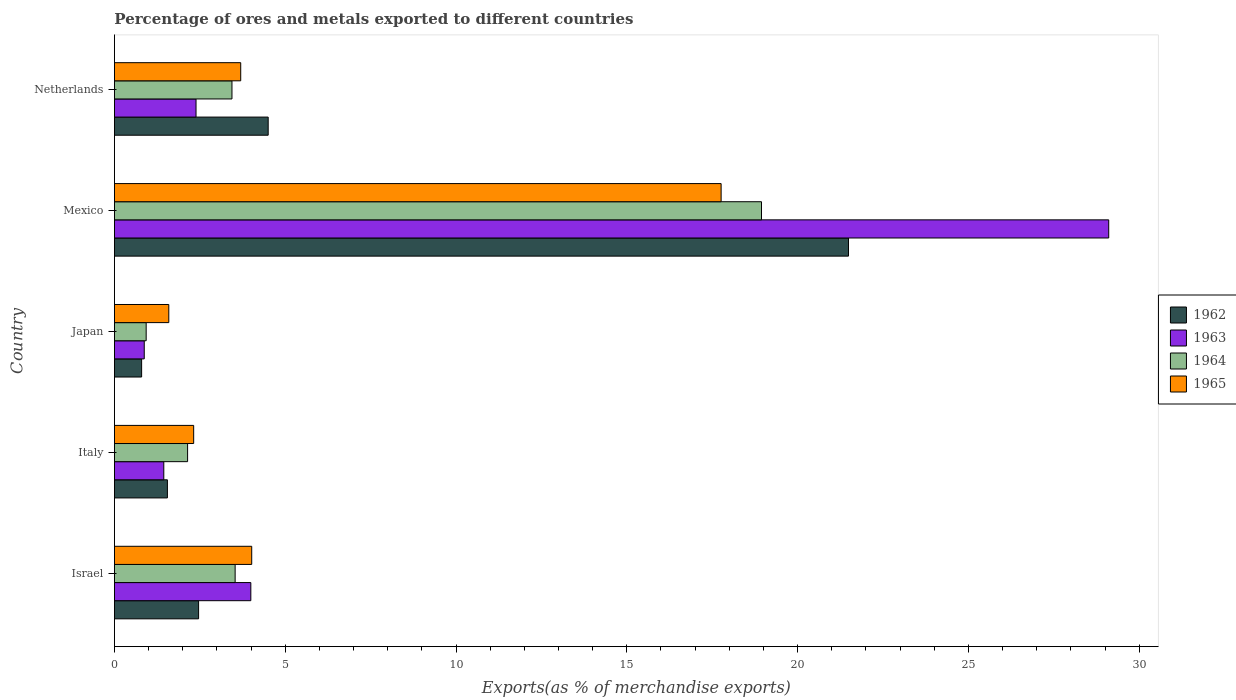How many groups of bars are there?
Keep it short and to the point. 5. How many bars are there on the 5th tick from the top?
Provide a succinct answer. 4. How many bars are there on the 5th tick from the bottom?
Offer a terse response. 4. What is the label of the 5th group of bars from the top?
Give a very brief answer. Israel. What is the percentage of exports to different countries in 1964 in Netherlands?
Provide a short and direct response. 3.44. Across all countries, what is the maximum percentage of exports to different countries in 1962?
Ensure brevity in your answer.  21.49. Across all countries, what is the minimum percentage of exports to different countries in 1964?
Your answer should be very brief. 0.93. In which country was the percentage of exports to different countries in 1965 minimum?
Ensure brevity in your answer.  Japan. What is the total percentage of exports to different countries in 1965 in the graph?
Your response must be concise. 29.39. What is the difference between the percentage of exports to different countries in 1963 in Japan and that in Netherlands?
Your response must be concise. -1.52. What is the difference between the percentage of exports to different countries in 1963 in Japan and the percentage of exports to different countries in 1964 in Netherlands?
Ensure brevity in your answer.  -2.57. What is the average percentage of exports to different countries in 1963 per country?
Your response must be concise. 7.56. What is the difference between the percentage of exports to different countries in 1963 and percentage of exports to different countries in 1964 in Netherlands?
Offer a terse response. -1.05. What is the ratio of the percentage of exports to different countries in 1963 in Italy to that in Netherlands?
Make the answer very short. 0.61. Is the difference between the percentage of exports to different countries in 1963 in Israel and Netherlands greater than the difference between the percentage of exports to different countries in 1964 in Israel and Netherlands?
Make the answer very short. Yes. What is the difference between the highest and the second highest percentage of exports to different countries in 1962?
Your answer should be compact. 16.99. What is the difference between the highest and the lowest percentage of exports to different countries in 1964?
Offer a very short reply. 18.01. Is it the case that in every country, the sum of the percentage of exports to different countries in 1964 and percentage of exports to different countries in 1963 is greater than the sum of percentage of exports to different countries in 1962 and percentage of exports to different countries in 1965?
Keep it short and to the point. No. What does the 1st bar from the top in Netherlands represents?
Your response must be concise. 1965. What does the 4th bar from the bottom in Israel represents?
Offer a terse response. 1965. What is the difference between two consecutive major ticks on the X-axis?
Your answer should be compact. 5. How many legend labels are there?
Offer a very short reply. 4. What is the title of the graph?
Your answer should be very brief. Percentage of ores and metals exported to different countries. Does "1987" appear as one of the legend labels in the graph?
Your answer should be very brief. No. What is the label or title of the X-axis?
Offer a very short reply. Exports(as % of merchandise exports). What is the label or title of the Y-axis?
Your answer should be compact. Country. What is the Exports(as % of merchandise exports) in 1962 in Israel?
Keep it short and to the point. 2.46. What is the Exports(as % of merchandise exports) of 1963 in Israel?
Offer a terse response. 3.99. What is the Exports(as % of merchandise exports) in 1964 in Israel?
Offer a very short reply. 3.53. What is the Exports(as % of merchandise exports) of 1965 in Israel?
Your answer should be very brief. 4.02. What is the Exports(as % of merchandise exports) of 1962 in Italy?
Give a very brief answer. 1.55. What is the Exports(as % of merchandise exports) of 1963 in Italy?
Your answer should be compact. 1.45. What is the Exports(as % of merchandise exports) in 1964 in Italy?
Offer a terse response. 2.14. What is the Exports(as % of merchandise exports) in 1965 in Italy?
Provide a short and direct response. 2.32. What is the Exports(as % of merchandise exports) in 1962 in Japan?
Offer a very short reply. 0.8. What is the Exports(as % of merchandise exports) in 1963 in Japan?
Your answer should be very brief. 0.87. What is the Exports(as % of merchandise exports) of 1964 in Japan?
Your response must be concise. 0.93. What is the Exports(as % of merchandise exports) of 1965 in Japan?
Keep it short and to the point. 1.59. What is the Exports(as % of merchandise exports) in 1962 in Mexico?
Provide a short and direct response. 21.49. What is the Exports(as % of merchandise exports) of 1963 in Mexico?
Provide a short and direct response. 29.11. What is the Exports(as % of merchandise exports) of 1964 in Mexico?
Offer a very short reply. 18.94. What is the Exports(as % of merchandise exports) of 1965 in Mexico?
Your response must be concise. 17.76. What is the Exports(as % of merchandise exports) in 1962 in Netherlands?
Your answer should be very brief. 4.5. What is the Exports(as % of merchandise exports) of 1963 in Netherlands?
Your answer should be very brief. 2.39. What is the Exports(as % of merchandise exports) of 1964 in Netherlands?
Offer a very short reply. 3.44. What is the Exports(as % of merchandise exports) in 1965 in Netherlands?
Offer a terse response. 3.7. Across all countries, what is the maximum Exports(as % of merchandise exports) in 1962?
Offer a very short reply. 21.49. Across all countries, what is the maximum Exports(as % of merchandise exports) of 1963?
Ensure brevity in your answer.  29.11. Across all countries, what is the maximum Exports(as % of merchandise exports) of 1964?
Make the answer very short. 18.94. Across all countries, what is the maximum Exports(as % of merchandise exports) of 1965?
Your answer should be compact. 17.76. Across all countries, what is the minimum Exports(as % of merchandise exports) in 1962?
Keep it short and to the point. 0.8. Across all countries, what is the minimum Exports(as % of merchandise exports) of 1963?
Offer a very short reply. 0.87. Across all countries, what is the minimum Exports(as % of merchandise exports) of 1964?
Offer a terse response. 0.93. Across all countries, what is the minimum Exports(as % of merchandise exports) of 1965?
Offer a terse response. 1.59. What is the total Exports(as % of merchandise exports) of 1962 in the graph?
Keep it short and to the point. 30.8. What is the total Exports(as % of merchandise exports) of 1963 in the graph?
Ensure brevity in your answer.  37.81. What is the total Exports(as % of merchandise exports) in 1964 in the graph?
Offer a very short reply. 28.99. What is the total Exports(as % of merchandise exports) in 1965 in the graph?
Your answer should be very brief. 29.39. What is the difference between the Exports(as % of merchandise exports) in 1962 in Israel and that in Italy?
Make the answer very short. 0.91. What is the difference between the Exports(as % of merchandise exports) of 1963 in Israel and that in Italy?
Provide a succinct answer. 2.55. What is the difference between the Exports(as % of merchandise exports) in 1964 in Israel and that in Italy?
Your answer should be compact. 1.39. What is the difference between the Exports(as % of merchandise exports) of 1965 in Israel and that in Italy?
Provide a succinct answer. 1.7. What is the difference between the Exports(as % of merchandise exports) of 1962 in Israel and that in Japan?
Give a very brief answer. 1.67. What is the difference between the Exports(as % of merchandise exports) of 1963 in Israel and that in Japan?
Ensure brevity in your answer.  3.12. What is the difference between the Exports(as % of merchandise exports) in 1964 in Israel and that in Japan?
Give a very brief answer. 2.6. What is the difference between the Exports(as % of merchandise exports) of 1965 in Israel and that in Japan?
Offer a terse response. 2.43. What is the difference between the Exports(as % of merchandise exports) in 1962 in Israel and that in Mexico?
Offer a very short reply. -19.03. What is the difference between the Exports(as % of merchandise exports) in 1963 in Israel and that in Mexico?
Your response must be concise. -25.12. What is the difference between the Exports(as % of merchandise exports) of 1964 in Israel and that in Mexico?
Your response must be concise. -15.41. What is the difference between the Exports(as % of merchandise exports) in 1965 in Israel and that in Mexico?
Provide a succinct answer. -13.74. What is the difference between the Exports(as % of merchandise exports) of 1962 in Israel and that in Netherlands?
Provide a succinct answer. -2.04. What is the difference between the Exports(as % of merchandise exports) of 1963 in Israel and that in Netherlands?
Your answer should be very brief. 1.6. What is the difference between the Exports(as % of merchandise exports) in 1964 in Israel and that in Netherlands?
Make the answer very short. 0.09. What is the difference between the Exports(as % of merchandise exports) in 1965 in Israel and that in Netherlands?
Give a very brief answer. 0.32. What is the difference between the Exports(as % of merchandise exports) of 1962 in Italy and that in Japan?
Keep it short and to the point. 0.75. What is the difference between the Exports(as % of merchandise exports) of 1963 in Italy and that in Japan?
Keep it short and to the point. 0.57. What is the difference between the Exports(as % of merchandise exports) of 1964 in Italy and that in Japan?
Provide a succinct answer. 1.21. What is the difference between the Exports(as % of merchandise exports) of 1965 in Italy and that in Japan?
Ensure brevity in your answer.  0.73. What is the difference between the Exports(as % of merchandise exports) in 1962 in Italy and that in Mexico?
Your answer should be very brief. -19.94. What is the difference between the Exports(as % of merchandise exports) of 1963 in Italy and that in Mexico?
Your response must be concise. -27.66. What is the difference between the Exports(as % of merchandise exports) in 1964 in Italy and that in Mexico?
Give a very brief answer. -16.8. What is the difference between the Exports(as % of merchandise exports) of 1965 in Italy and that in Mexico?
Your response must be concise. -15.44. What is the difference between the Exports(as % of merchandise exports) of 1962 in Italy and that in Netherlands?
Offer a terse response. -2.95. What is the difference between the Exports(as % of merchandise exports) in 1963 in Italy and that in Netherlands?
Your answer should be very brief. -0.94. What is the difference between the Exports(as % of merchandise exports) in 1964 in Italy and that in Netherlands?
Ensure brevity in your answer.  -1.3. What is the difference between the Exports(as % of merchandise exports) of 1965 in Italy and that in Netherlands?
Provide a short and direct response. -1.38. What is the difference between the Exports(as % of merchandise exports) of 1962 in Japan and that in Mexico?
Make the answer very short. -20.69. What is the difference between the Exports(as % of merchandise exports) of 1963 in Japan and that in Mexico?
Give a very brief answer. -28.24. What is the difference between the Exports(as % of merchandise exports) of 1964 in Japan and that in Mexico?
Offer a very short reply. -18.01. What is the difference between the Exports(as % of merchandise exports) of 1965 in Japan and that in Mexico?
Give a very brief answer. -16.17. What is the difference between the Exports(as % of merchandise exports) in 1962 in Japan and that in Netherlands?
Your answer should be compact. -3.7. What is the difference between the Exports(as % of merchandise exports) of 1963 in Japan and that in Netherlands?
Keep it short and to the point. -1.52. What is the difference between the Exports(as % of merchandise exports) of 1964 in Japan and that in Netherlands?
Provide a short and direct response. -2.51. What is the difference between the Exports(as % of merchandise exports) of 1965 in Japan and that in Netherlands?
Provide a succinct answer. -2.11. What is the difference between the Exports(as % of merchandise exports) in 1962 in Mexico and that in Netherlands?
Offer a very short reply. 16.99. What is the difference between the Exports(as % of merchandise exports) in 1963 in Mexico and that in Netherlands?
Provide a succinct answer. 26.72. What is the difference between the Exports(as % of merchandise exports) of 1964 in Mexico and that in Netherlands?
Your answer should be very brief. 15.5. What is the difference between the Exports(as % of merchandise exports) in 1965 in Mexico and that in Netherlands?
Your answer should be compact. 14.06. What is the difference between the Exports(as % of merchandise exports) in 1962 in Israel and the Exports(as % of merchandise exports) in 1963 in Italy?
Give a very brief answer. 1.02. What is the difference between the Exports(as % of merchandise exports) of 1962 in Israel and the Exports(as % of merchandise exports) of 1964 in Italy?
Your answer should be compact. 0.32. What is the difference between the Exports(as % of merchandise exports) of 1962 in Israel and the Exports(as % of merchandise exports) of 1965 in Italy?
Ensure brevity in your answer.  0.14. What is the difference between the Exports(as % of merchandise exports) in 1963 in Israel and the Exports(as % of merchandise exports) in 1964 in Italy?
Your answer should be very brief. 1.85. What is the difference between the Exports(as % of merchandise exports) in 1963 in Israel and the Exports(as % of merchandise exports) in 1965 in Italy?
Ensure brevity in your answer.  1.67. What is the difference between the Exports(as % of merchandise exports) of 1964 in Israel and the Exports(as % of merchandise exports) of 1965 in Italy?
Your response must be concise. 1.21. What is the difference between the Exports(as % of merchandise exports) in 1962 in Israel and the Exports(as % of merchandise exports) in 1963 in Japan?
Your answer should be very brief. 1.59. What is the difference between the Exports(as % of merchandise exports) of 1962 in Israel and the Exports(as % of merchandise exports) of 1964 in Japan?
Keep it short and to the point. 1.53. What is the difference between the Exports(as % of merchandise exports) of 1962 in Israel and the Exports(as % of merchandise exports) of 1965 in Japan?
Keep it short and to the point. 0.87. What is the difference between the Exports(as % of merchandise exports) of 1963 in Israel and the Exports(as % of merchandise exports) of 1964 in Japan?
Your response must be concise. 3.06. What is the difference between the Exports(as % of merchandise exports) of 1963 in Israel and the Exports(as % of merchandise exports) of 1965 in Japan?
Give a very brief answer. 2.4. What is the difference between the Exports(as % of merchandise exports) of 1964 in Israel and the Exports(as % of merchandise exports) of 1965 in Japan?
Your response must be concise. 1.94. What is the difference between the Exports(as % of merchandise exports) in 1962 in Israel and the Exports(as % of merchandise exports) in 1963 in Mexico?
Your response must be concise. -26.64. What is the difference between the Exports(as % of merchandise exports) in 1962 in Israel and the Exports(as % of merchandise exports) in 1964 in Mexico?
Offer a terse response. -16.48. What is the difference between the Exports(as % of merchandise exports) in 1962 in Israel and the Exports(as % of merchandise exports) in 1965 in Mexico?
Ensure brevity in your answer.  -15.3. What is the difference between the Exports(as % of merchandise exports) of 1963 in Israel and the Exports(as % of merchandise exports) of 1964 in Mexico?
Your answer should be very brief. -14.95. What is the difference between the Exports(as % of merchandise exports) in 1963 in Israel and the Exports(as % of merchandise exports) in 1965 in Mexico?
Offer a terse response. -13.77. What is the difference between the Exports(as % of merchandise exports) of 1964 in Israel and the Exports(as % of merchandise exports) of 1965 in Mexico?
Provide a short and direct response. -14.23. What is the difference between the Exports(as % of merchandise exports) of 1962 in Israel and the Exports(as % of merchandise exports) of 1963 in Netherlands?
Offer a terse response. 0.07. What is the difference between the Exports(as % of merchandise exports) in 1962 in Israel and the Exports(as % of merchandise exports) in 1964 in Netherlands?
Provide a short and direct response. -0.98. What is the difference between the Exports(as % of merchandise exports) in 1962 in Israel and the Exports(as % of merchandise exports) in 1965 in Netherlands?
Make the answer very short. -1.23. What is the difference between the Exports(as % of merchandise exports) of 1963 in Israel and the Exports(as % of merchandise exports) of 1964 in Netherlands?
Make the answer very short. 0.55. What is the difference between the Exports(as % of merchandise exports) of 1963 in Israel and the Exports(as % of merchandise exports) of 1965 in Netherlands?
Your answer should be compact. 0.3. What is the difference between the Exports(as % of merchandise exports) of 1964 in Israel and the Exports(as % of merchandise exports) of 1965 in Netherlands?
Offer a terse response. -0.16. What is the difference between the Exports(as % of merchandise exports) in 1962 in Italy and the Exports(as % of merchandise exports) in 1963 in Japan?
Ensure brevity in your answer.  0.68. What is the difference between the Exports(as % of merchandise exports) in 1962 in Italy and the Exports(as % of merchandise exports) in 1964 in Japan?
Give a very brief answer. 0.62. What is the difference between the Exports(as % of merchandise exports) in 1962 in Italy and the Exports(as % of merchandise exports) in 1965 in Japan?
Provide a short and direct response. -0.04. What is the difference between the Exports(as % of merchandise exports) of 1963 in Italy and the Exports(as % of merchandise exports) of 1964 in Japan?
Your answer should be very brief. 0.52. What is the difference between the Exports(as % of merchandise exports) of 1963 in Italy and the Exports(as % of merchandise exports) of 1965 in Japan?
Provide a short and direct response. -0.15. What is the difference between the Exports(as % of merchandise exports) of 1964 in Italy and the Exports(as % of merchandise exports) of 1965 in Japan?
Provide a short and direct response. 0.55. What is the difference between the Exports(as % of merchandise exports) in 1962 in Italy and the Exports(as % of merchandise exports) in 1963 in Mexico?
Offer a very short reply. -27.56. What is the difference between the Exports(as % of merchandise exports) in 1962 in Italy and the Exports(as % of merchandise exports) in 1964 in Mexico?
Give a very brief answer. -17.39. What is the difference between the Exports(as % of merchandise exports) of 1962 in Italy and the Exports(as % of merchandise exports) of 1965 in Mexico?
Your response must be concise. -16.21. What is the difference between the Exports(as % of merchandise exports) in 1963 in Italy and the Exports(as % of merchandise exports) in 1964 in Mexico?
Offer a very short reply. -17.5. What is the difference between the Exports(as % of merchandise exports) in 1963 in Italy and the Exports(as % of merchandise exports) in 1965 in Mexico?
Ensure brevity in your answer.  -16.32. What is the difference between the Exports(as % of merchandise exports) of 1964 in Italy and the Exports(as % of merchandise exports) of 1965 in Mexico?
Make the answer very short. -15.62. What is the difference between the Exports(as % of merchandise exports) of 1962 in Italy and the Exports(as % of merchandise exports) of 1963 in Netherlands?
Your response must be concise. -0.84. What is the difference between the Exports(as % of merchandise exports) in 1962 in Italy and the Exports(as % of merchandise exports) in 1964 in Netherlands?
Offer a terse response. -1.89. What is the difference between the Exports(as % of merchandise exports) of 1962 in Italy and the Exports(as % of merchandise exports) of 1965 in Netherlands?
Offer a terse response. -2.15. What is the difference between the Exports(as % of merchandise exports) in 1963 in Italy and the Exports(as % of merchandise exports) in 1964 in Netherlands?
Make the answer very short. -2. What is the difference between the Exports(as % of merchandise exports) in 1963 in Italy and the Exports(as % of merchandise exports) in 1965 in Netherlands?
Provide a succinct answer. -2.25. What is the difference between the Exports(as % of merchandise exports) of 1964 in Italy and the Exports(as % of merchandise exports) of 1965 in Netherlands?
Ensure brevity in your answer.  -1.56. What is the difference between the Exports(as % of merchandise exports) in 1962 in Japan and the Exports(as % of merchandise exports) in 1963 in Mexico?
Provide a short and direct response. -28.31. What is the difference between the Exports(as % of merchandise exports) in 1962 in Japan and the Exports(as % of merchandise exports) in 1964 in Mexico?
Your answer should be very brief. -18.15. What is the difference between the Exports(as % of merchandise exports) of 1962 in Japan and the Exports(as % of merchandise exports) of 1965 in Mexico?
Provide a succinct answer. -16.97. What is the difference between the Exports(as % of merchandise exports) of 1963 in Japan and the Exports(as % of merchandise exports) of 1964 in Mexico?
Your answer should be compact. -18.07. What is the difference between the Exports(as % of merchandise exports) of 1963 in Japan and the Exports(as % of merchandise exports) of 1965 in Mexico?
Make the answer very short. -16.89. What is the difference between the Exports(as % of merchandise exports) of 1964 in Japan and the Exports(as % of merchandise exports) of 1965 in Mexico?
Make the answer very short. -16.83. What is the difference between the Exports(as % of merchandise exports) in 1962 in Japan and the Exports(as % of merchandise exports) in 1963 in Netherlands?
Offer a very short reply. -1.59. What is the difference between the Exports(as % of merchandise exports) of 1962 in Japan and the Exports(as % of merchandise exports) of 1964 in Netherlands?
Your answer should be compact. -2.64. What is the difference between the Exports(as % of merchandise exports) of 1962 in Japan and the Exports(as % of merchandise exports) of 1965 in Netherlands?
Ensure brevity in your answer.  -2.9. What is the difference between the Exports(as % of merchandise exports) of 1963 in Japan and the Exports(as % of merchandise exports) of 1964 in Netherlands?
Give a very brief answer. -2.57. What is the difference between the Exports(as % of merchandise exports) of 1963 in Japan and the Exports(as % of merchandise exports) of 1965 in Netherlands?
Offer a very short reply. -2.82. What is the difference between the Exports(as % of merchandise exports) in 1964 in Japan and the Exports(as % of merchandise exports) in 1965 in Netherlands?
Your answer should be compact. -2.77. What is the difference between the Exports(as % of merchandise exports) in 1962 in Mexico and the Exports(as % of merchandise exports) in 1963 in Netherlands?
Ensure brevity in your answer.  19.1. What is the difference between the Exports(as % of merchandise exports) of 1962 in Mexico and the Exports(as % of merchandise exports) of 1964 in Netherlands?
Offer a terse response. 18.05. What is the difference between the Exports(as % of merchandise exports) in 1962 in Mexico and the Exports(as % of merchandise exports) in 1965 in Netherlands?
Keep it short and to the point. 17.79. What is the difference between the Exports(as % of merchandise exports) in 1963 in Mexico and the Exports(as % of merchandise exports) in 1964 in Netherlands?
Your response must be concise. 25.67. What is the difference between the Exports(as % of merchandise exports) of 1963 in Mexico and the Exports(as % of merchandise exports) of 1965 in Netherlands?
Offer a very short reply. 25.41. What is the difference between the Exports(as % of merchandise exports) in 1964 in Mexico and the Exports(as % of merchandise exports) in 1965 in Netherlands?
Give a very brief answer. 15.25. What is the average Exports(as % of merchandise exports) of 1962 per country?
Keep it short and to the point. 6.16. What is the average Exports(as % of merchandise exports) of 1963 per country?
Provide a short and direct response. 7.56. What is the average Exports(as % of merchandise exports) of 1964 per country?
Ensure brevity in your answer.  5.8. What is the average Exports(as % of merchandise exports) in 1965 per country?
Make the answer very short. 5.88. What is the difference between the Exports(as % of merchandise exports) of 1962 and Exports(as % of merchandise exports) of 1963 in Israel?
Give a very brief answer. -1.53. What is the difference between the Exports(as % of merchandise exports) of 1962 and Exports(as % of merchandise exports) of 1964 in Israel?
Provide a short and direct response. -1.07. What is the difference between the Exports(as % of merchandise exports) in 1962 and Exports(as % of merchandise exports) in 1965 in Israel?
Your response must be concise. -1.56. What is the difference between the Exports(as % of merchandise exports) of 1963 and Exports(as % of merchandise exports) of 1964 in Israel?
Your answer should be compact. 0.46. What is the difference between the Exports(as % of merchandise exports) of 1963 and Exports(as % of merchandise exports) of 1965 in Israel?
Offer a very short reply. -0.03. What is the difference between the Exports(as % of merchandise exports) in 1964 and Exports(as % of merchandise exports) in 1965 in Israel?
Give a very brief answer. -0.49. What is the difference between the Exports(as % of merchandise exports) in 1962 and Exports(as % of merchandise exports) in 1963 in Italy?
Provide a short and direct response. 0.11. What is the difference between the Exports(as % of merchandise exports) of 1962 and Exports(as % of merchandise exports) of 1964 in Italy?
Ensure brevity in your answer.  -0.59. What is the difference between the Exports(as % of merchandise exports) of 1962 and Exports(as % of merchandise exports) of 1965 in Italy?
Your answer should be compact. -0.77. What is the difference between the Exports(as % of merchandise exports) in 1963 and Exports(as % of merchandise exports) in 1964 in Italy?
Your answer should be compact. -0.7. What is the difference between the Exports(as % of merchandise exports) of 1963 and Exports(as % of merchandise exports) of 1965 in Italy?
Make the answer very short. -0.87. What is the difference between the Exports(as % of merchandise exports) in 1964 and Exports(as % of merchandise exports) in 1965 in Italy?
Your answer should be very brief. -0.18. What is the difference between the Exports(as % of merchandise exports) of 1962 and Exports(as % of merchandise exports) of 1963 in Japan?
Your answer should be compact. -0.08. What is the difference between the Exports(as % of merchandise exports) in 1962 and Exports(as % of merchandise exports) in 1964 in Japan?
Offer a very short reply. -0.13. What is the difference between the Exports(as % of merchandise exports) of 1962 and Exports(as % of merchandise exports) of 1965 in Japan?
Your response must be concise. -0.8. What is the difference between the Exports(as % of merchandise exports) in 1963 and Exports(as % of merchandise exports) in 1964 in Japan?
Offer a very short reply. -0.06. What is the difference between the Exports(as % of merchandise exports) in 1963 and Exports(as % of merchandise exports) in 1965 in Japan?
Make the answer very short. -0.72. What is the difference between the Exports(as % of merchandise exports) of 1964 and Exports(as % of merchandise exports) of 1965 in Japan?
Provide a short and direct response. -0.66. What is the difference between the Exports(as % of merchandise exports) of 1962 and Exports(as % of merchandise exports) of 1963 in Mexico?
Keep it short and to the point. -7.62. What is the difference between the Exports(as % of merchandise exports) in 1962 and Exports(as % of merchandise exports) in 1964 in Mexico?
Your answer should be compact. 2.55. What is the difference between the Exports(as % of merchandise exports) of 1962 and Exports(as % of merchandise exports) of 1965 in Mexico?
Keep it short and to the point. 3.73. What is the difference between the Exports(as % of merchandise exports) in 1963 and Exports(as % of merchandise exports) in 1964 in Mexico?
Make the answer very short. 10.16. What is the difference between the Exports(as % of merchandise exports) in 1963 and Exports(as % of merchandise exports) in 1965 in Mexico?
Keep it short and to the point. 11.35. What is the difference between the Exports(as % of merchandise exports) of 1964 and Exports(as % of merchandise exports) of 1965 in Mexico?
Your answer should be compact. 1.18. What is the difference between the Exports(as % of merchandise exports) of 1962 and Exports(as % of merchandise exports) of 1963 in Netherlands?
Give a very brief answer. 2.11. What is the difference between the Exports(as % of merchandise exports) of 1962 and Exports(as % of merchandise exports) of 1964 in Netherlands?
Make the answer very short. 1.06. What is the difference between the Exports(as % of merchandise exports) of 1962 and Exports(as % of merchandise exports) of 1965 in Netherlands?
Provide a succinct answer. 0.8. What is the difference between the Exports(as % of merchandise exports) of 1963 and Exports(as % of merchandise exports) of 1964 in Netherlands?
Your response must be concise. -1.05. What is the difference between the Exports(as % of merchandise exports) of 1963 and Exports(as % of merchandise exports) of 1965 in Netherlands?
Offer a terse response. -1.31. What is the difference between the Exports(as % of merchandise exports) in 1964 and Exports(as % of merchandise exports) in 1965 in Netherlands?
Your answer should be compact. -0.26. What is the ratio of the Exports(as % of merchandise exports) of 1962 in Israel to that in Italy?
Provide a short and direct response. 1.59. What is the ratio of the Exports(as % of merchandise exports) of 1963 in Israel to that in Italy?
Your answer should be very brief. 2.76. What is the ratio of the Exports(as % of merchandise exports) in 1964 in Israel to that in Italy?
Provide a short and direct response. 1.65. What is the ratio of the Exports(as % of merchandise exports) of 1965 in Israel to that in Italy?
Your answer should be very brief. 1.73. What is the ratio of the Exports(as % of merchandise exports) of 1962 in Israel to that in Japan?
Provide a succinct answer. 3.09. What is the ratio of the Exports(as % of merchandise exports) of 1963 in Israel to that in Japan?
Offer a very short reply. 4.57. What is the ratio of the Exports(as % of merchandise exports) of 1964 in Israel to that in Japan?
Give a very brief answer. 3.8. What is the ratio of the Exports(as % of merchandise exports) of 1965 in Israel to that in Japan?
Provide a succinct answer. 2.52. What is the ratio of the Exports(as % of merchandise exports) of 1962 in Israel to that in Mexico?
Provide a succinct answer. 0.11. What is the ratio of the Exports(as % of merchandise exports) in 1963 in Israel to that in Mexico?
Your answer should be compact. 0.14. What is the ratio of the Exports(as % of merchandise exports) in 1964 in Israel to that in Mexico?
Make the answer very short. 0.19. What is the ratio of the Exports(as % of merchandise exports) in 1965 in Israel to that in Mexico?
Make the answer very short. 0.23. What is the ratio of the Exports(as % of merchandise exports) in 1962 in Israel to that in Netherlands?
Make the answer very short. 0.55. What is the ratio of the Exports(as % of merchandise exports) of 1963 in Israel to that in Netherlands?
Make the answer very short. 1.67. What is the ratio of the Exports(as % of merchandise exports) in 1965 in Israel to that in Netherlands?
Provide a short and direct response. 1.09. What is the ratio of the Exports(as % of merchandise exports) of 1962 in Italy to that in Japan?
Provide a short and direct response. 1.95. What is the ratio of the Exports(as % of merchandise exports) of 1963 in Italy to that in Japan?
Your answer should be compact. 1.66. What is the ratio of the Exports(as % of merchandise exports) of 1964 in Italy to that in Japan?
Give a very brief answer. 2.31. What is the ratio of the Exports(as % of merchandise exports) in 1965 in Italy to that in Japan?
Offer a terse response. 1.46. What is the ratio of the Exports(as % of merchandise exports) in 1962 in Italy to that in Mexico?
Provide a short and direct response. 0.07. What is the ratio of the Exports(as % of merchandise exports) of 1963 in Italy to that in Mexico?
Give a very brief answer. 0.05. What is the ratio of the Exports(as % of merchandise exports) of 1964 in Italy to that in Mexico?
Make the answer very short. 0.11. What is the ratio of the Exports(as % of merchandise exports) in 1965 in Italy to that in Mexico?
Make the answer very short. 0.13. What is the ratio of the Exports(as % of merchandise exports) in 1962 in Italy to that in Netherlands?
Offer a terse response. 0.34. What is the ratio of the Exports(as % of merchandise exports) of 1963 in Italy to that in Netherlands?
Keep it short and to the point. 0.6. What is the ratio of the Exports(as % of merchandise exports) in 1964 in Italy to that in Netherlands?
Make the answer very short. 0.62. What is the ratio of the Exports(as % of merchandise exports) of 1965 in Italy to that in Netherlands?
Keep it short and to the point. 0.63. What is the ratio of the Exports(as % of merchandise exports) in 1962 in Japan to that in Mexico?
Your response must be concise. 0.04. What is the ratio of the Exports(as % of merchandise exports) in 1964 in Japan to that in Mexico?
Provide a short and direct response. 0.05. What is the ratio of the Exports(as % of merchandise exports) in 1965 in Japan to that in Mexico?
Your answer should be compact. 0.09. What is the ratio of the Exports(as % of merchandise exports) of 1962 in Japan to that in Netherlands?
Make the answer very short. 0.18. What is the ratio of the Exports(as % of merchandise exports) in 1963 in Japan to that in Netherlands?
Ensure brevity in your answer.  0.37. What is the ratio of the Exports(as % of merchandise exports) in 1964 in Japan to that in Netherlands?
Make the answer very short. 0.27. What is the ratio of the Exports(as % of merchandise exports) in 1965 in Japan to that in Netherlands?
Ensure brevity in your answer.  0.43. What is the ratio of the Exports(as % of merchandise exports) in 1962 in Mexico to that in Netherlands?
Provide a short and direct response. 4.77. What is the ratio of the Exports(as % of merchandise exports) of 1963 in Mexico to that in Netherlands?
Ensure brevity in your answer.  12.18. What is the ratio of the Exports(as % of merchandise exports) of 1964 in Mexico to that in Netherlands?
Your answer should be very brief. 5.51. What is the ratio of the Exports(as % of merchandise exports) in 1965 in Mexico to that in Netherlands?
Your answer should be very brief. 4.8. What is the difference between the highest and the second highest Exports(as % of merchandise exports) of 1962?
Make the answer very short. 16.99. What is the difference between the highest and the second highest Exports(as % of merchandise exports) of 1963?
Ensure brevity in your answer.  25.12. What is the difference between the highest and the second highest Exports(as % of merchandise exports) of 1964?
Your answer should be compact. 15.41. What is the difference between the highest and the second highest Exports(as % of merchandise exports) in 1965?
Make the answer very short. 13.74. What is the difference between the highest and the lowest Exports(as % of merchandise exports) in 1962?
Provide a short and direct response. 20.69. What is the difference between the highest and the lowest Exports(as % of merchandise exports) of 1963?
Provide a succinct answer. 28.24. What is the difference between the highest and the lowest Exports(as % of merchandise exports) in 1964?
Ensure brevity in your answer.  18.01. What is the difference between the highest and the lowest Exports(as % of merchandise exports) in 1965?
Your answer should be compact. 16.17. 